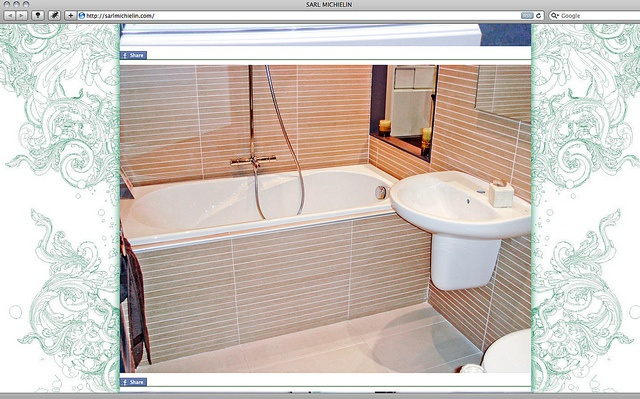Describe the objects in this image and their specific colors. I can see sink in lightgray, tan, and darkgray tones, sink in lightgray and darkgray tones, and toilet in lightgray, white, darkgray, and gray tones in this image. 